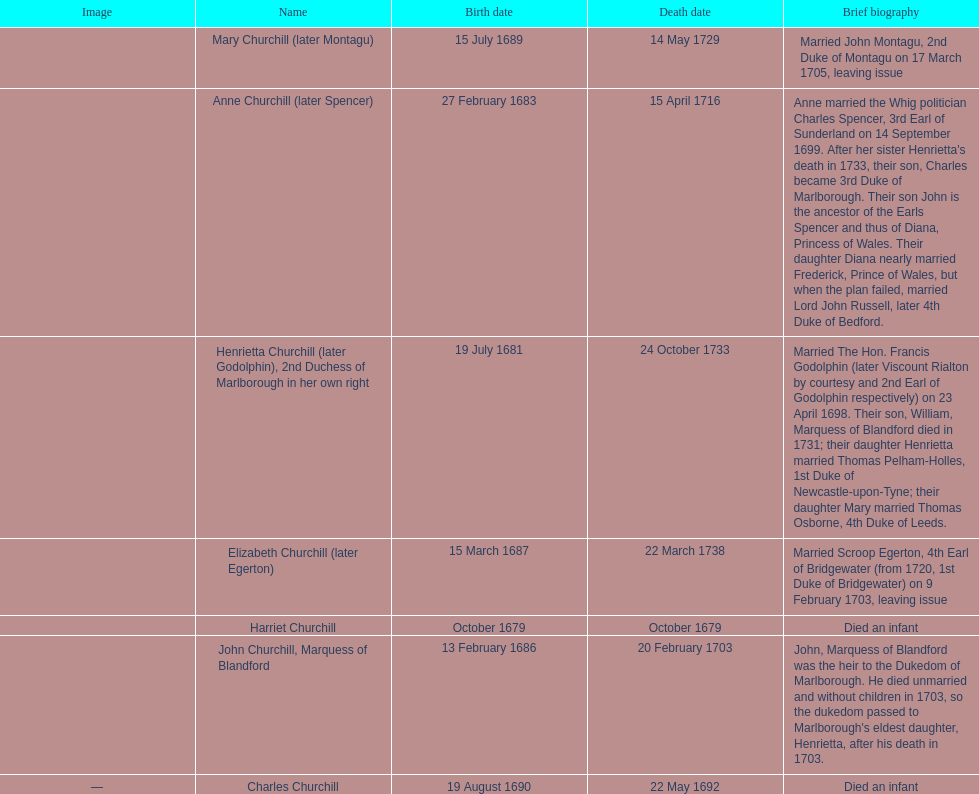What is the total number of children born after 1675? 7. 